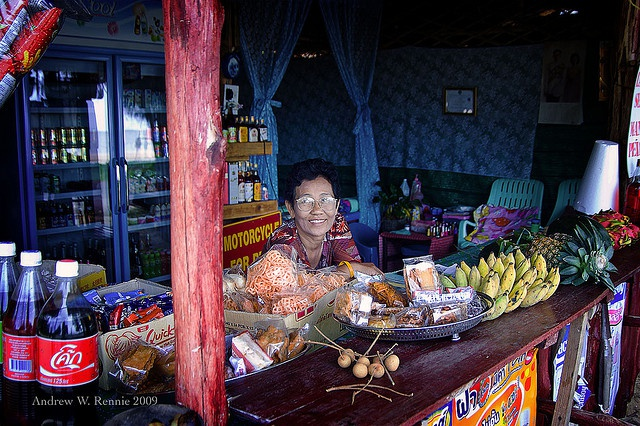Describe the objects in this image and their specific colors. I can see refrigerator in lightblue, black, navy, gray, and blue tones, bottle in lightblue, black, red, white, and navy tones, people in lightblue, black, darkgray, and gray tones, bottle in lightblue, black, navy, olive, and gray tones, and bottle in lightblue, black, blue, and white tones in this image. 